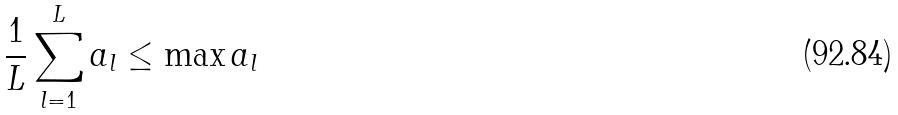<formula> <loc_0><loc_0><loc_500><loc_500>\frac { 1 } { L } \sum _ { l = 1 } ^ { L } a _ { l } \leq \max a _ { l }</formula> 